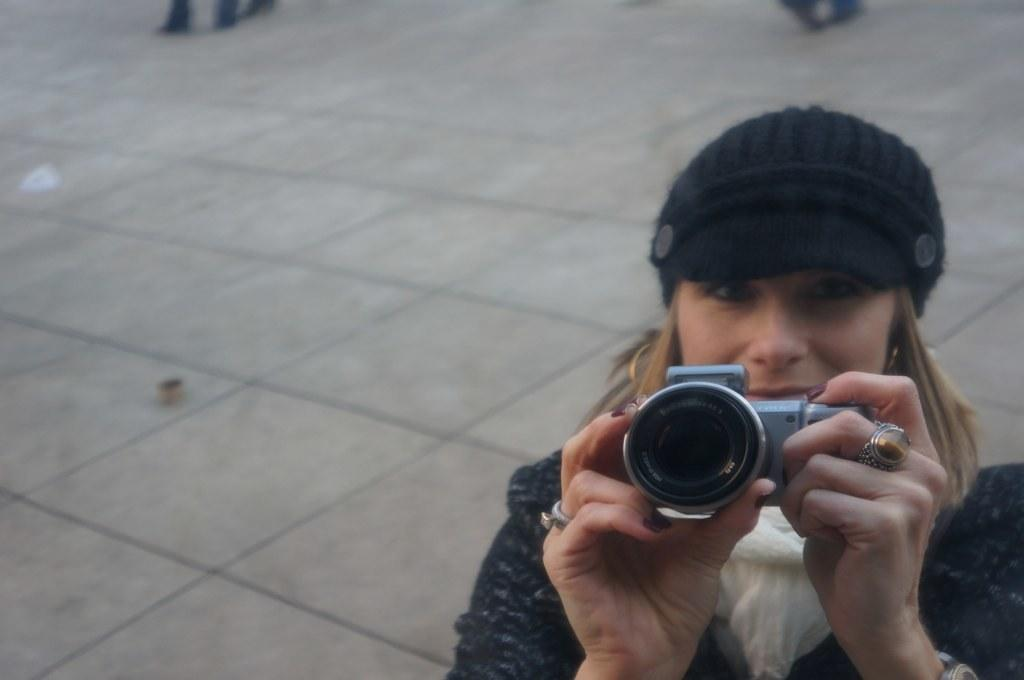Who is the main subject in the image? There is a woman in the image. What is the woman wearing on her upper body? The woman is wearing a black jacket. What type of headwear is the woman wearing? The woman is wearing a cap. What is the woman holding in her hands? The woman is holding a camera. What type of cord is the woman using to connect her camera to the computer in the image? There is no cord or computer present in the image; the woman is simply holding a camera. 